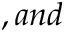<formula> <loc_0><loc_0><loc_500><loc_500>, a n d</formula> 